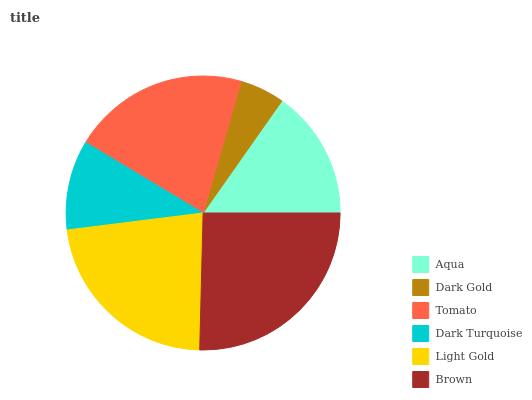Is Dark Gold the minimum?
Answer yes or no. Yes. Is Brown the maximum?
Answer yes or no. Yes. Is Tomato the minimum?
Answer yes or no. No. Is Tomato the maximum?
Answer yes or no. No. Is Tomato greater than Dark Gold?
Answer yes or no. Yes. Is Dark Gold less than Tomato?
Answer yes or no. Yes. Is Dark Gold greater than Tomato?
Answer yes or no. No. Is Tomato less than Dark Gold?
Answer yes or no. No. Is Tomato the high median?
Answer yes or no. Yes. Is Aqua the low median?
Answer yes or no. Yes. Is Dark Gold the high median?
Answer yes or no. No. Is Tomato the low median?
Answer yes or no. No. 